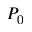Convert formula to latex. <formula><loc_0><loc_0><loc_500><loc_500>P _ { 0 }</formula> 